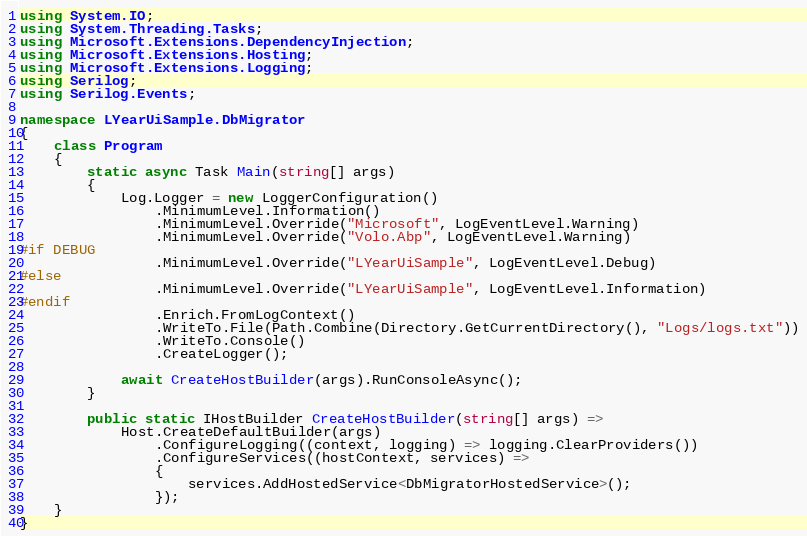Convert code to text. <code><loc_0><loc_0><loc_500><loc_500><_C#_>using System.IO;
using System.Threading.Tasks;
using Microsoft.Extensions.DependencyInjection;
using Microsoft.Extensions.Hosting;
using Microsoft.Extensions.Logging;
using Serilog;
using Serilog.Events;

namespace LYearUiSample.DbMigrator
{
    class Program
    {
        static async Task Main(string[] args)
        {
            Log.Logger = new LoggerConfiguration()
                .MinimumLevel.Information()
                .MinimumLevel.Override("Microsoft", LogEventLevel.Warning)
                .MinimumLevel.Override("Volo.Abp", LogEventLevel.Warning)
#if DEBUG
                .MinimumLevel.Override("LYearUiSample", LogEventLevel.Debug)
#else
                .MinimumLevel.Override("LYearUiSample", LogEventLevel.Information)
#endif
                .Enrich.FromLogContext()
                .WriteTo.File(Path.Combine(Directory.GetCurrentDirectory(), "Logs/logs.txt"))
                .WriteTo.Console()
                .CreateLogger();

            await CreateHostBuilder(args).RunConsoleAsync();
        }

        public static IHostBuilder CreateHostBuilder(string[] args) =>
            Host.CreateDefaultBuilder(args)
                .ConfigureLogging((context, logging) => logging.ClearProviders())
                .ConfigureServices((hostContext, services) =>
                {
                    services.AddHostedService<DbMigratorHostedService>();
                });
    }
}
</code> 